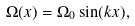Convert formula to latex. <formula><loc_0><loc_0><loc_500><loc_500>\Omega ( x ) = \Omega _ { 0 } \sin ( k x ) ,</formula> 